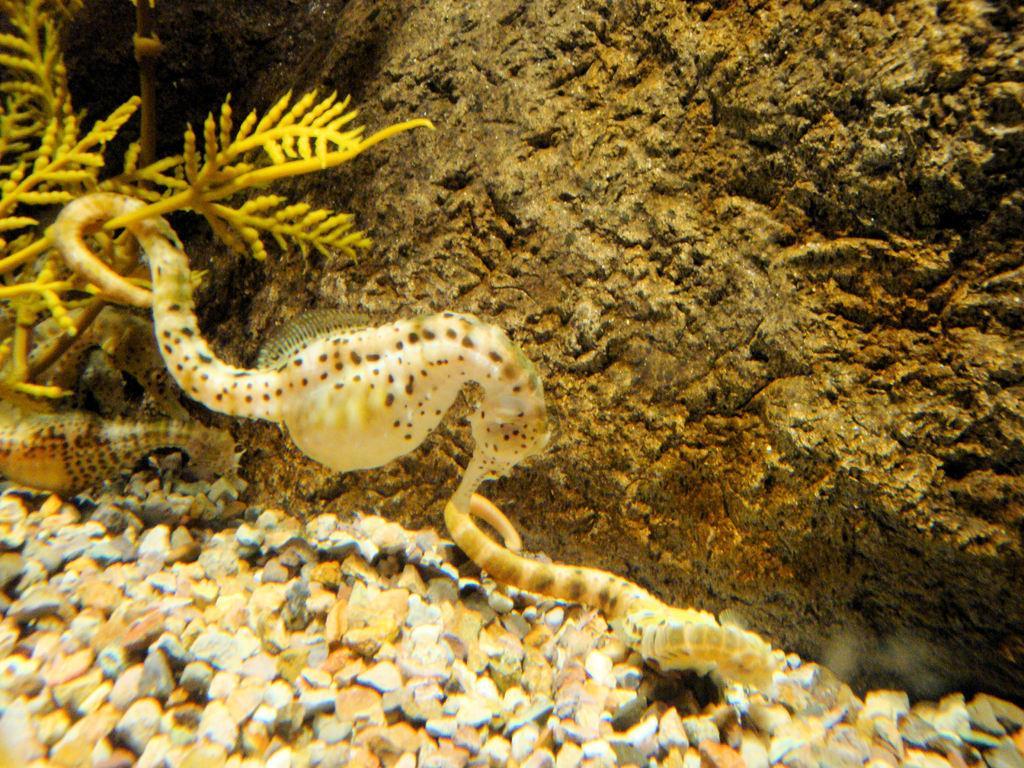Describe this image in one or two sentences. This is the picture of a under water in which there is a seahorse, plant, marbles and a rock to the side. 